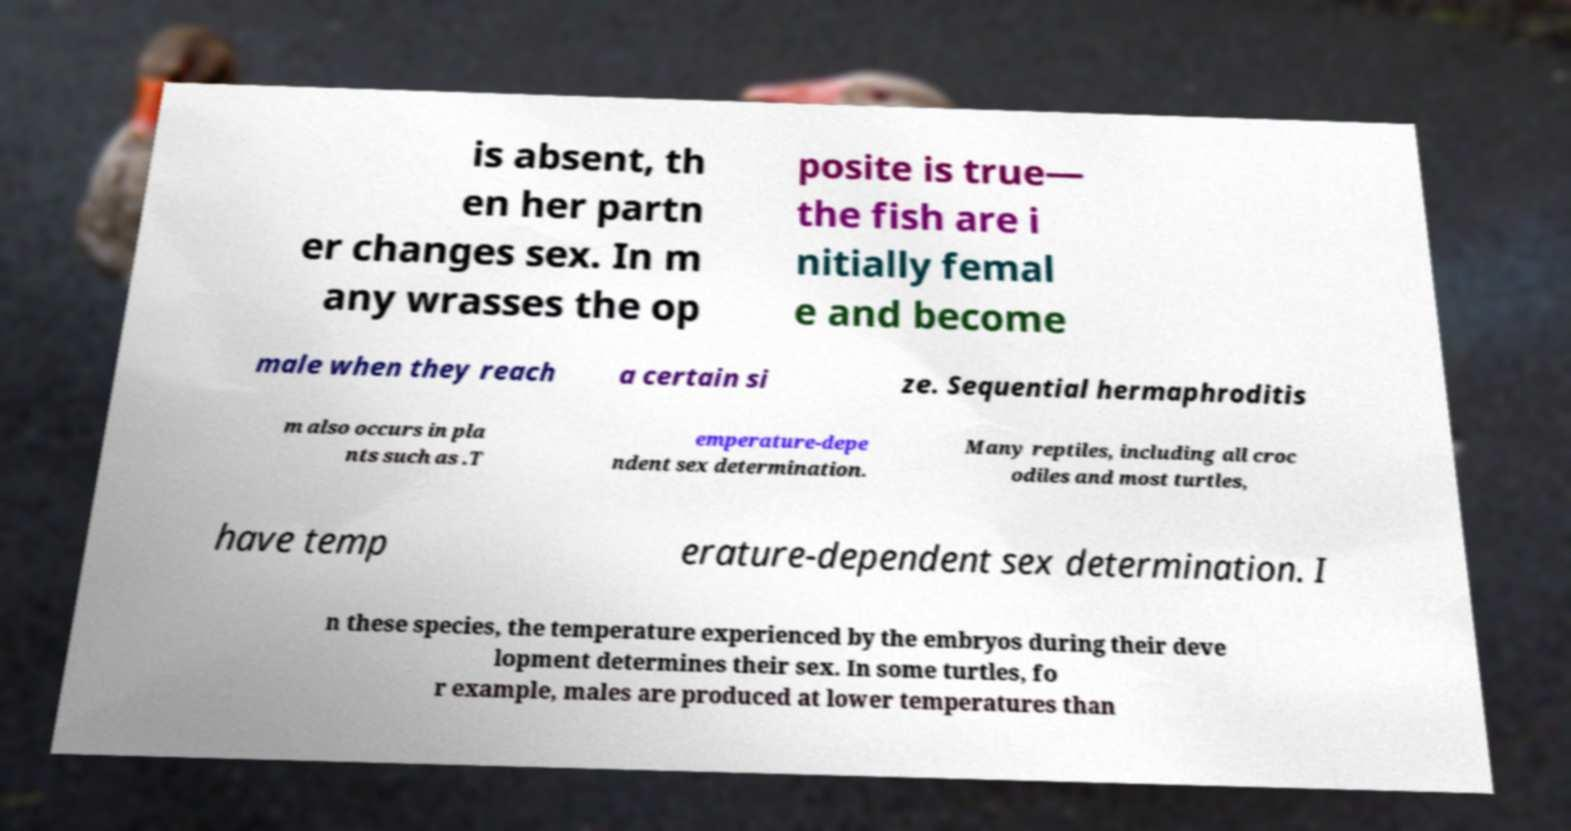What messages or text are displayed in this image? I need them in a readable, typed format. is absent, th en her partn er changes sex. In m any wrasses the op posite is true— the fish are i nitially femal e and become male when they reach a certain si ze. Sequential hermaphroditis m also occurs in pla nts such as .T emperature-depe ndent sex determination. Many reptiles, including all croc odiles and most turtles, have temp erature-dependent sex determination. I n these species, the temperature experienced by the embryos during their deve lopment determines their sex. In some turtles, fo r example, males are produced at lower temperatures than 